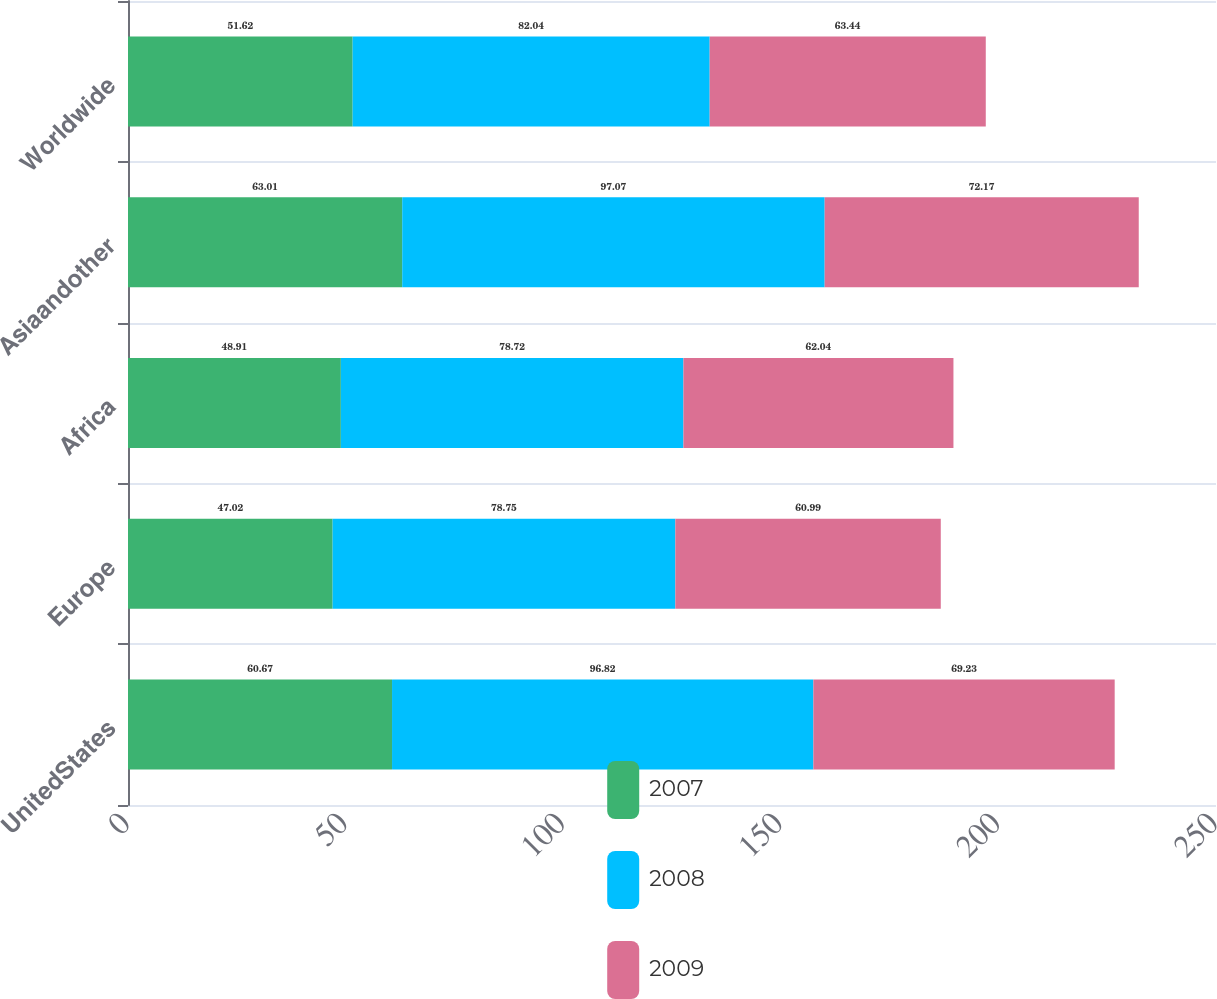<chart> <loc_0><loc_0><loc_500><loc_500><stacked_bar_chart><ecel><fcel>UnitedStates<fcel>Europe<fcel>Africa<fcel>Asiaandother<fcel>Worldwide<nl><fcel>2007<fcel>60.67<fcel>47.02<fcel>48.91<fcel>63.01<fcel>51.62<nl><fcel>2008<fcel>96.82<fcel>78.75<fcel>78.72<fcel>97.07<fcel>82.04<nl><fcel>2009<fcel>69.23<fcel>60.99<fcel>62.04<fcel>72.17<fcel>63.44<nl></chart> 